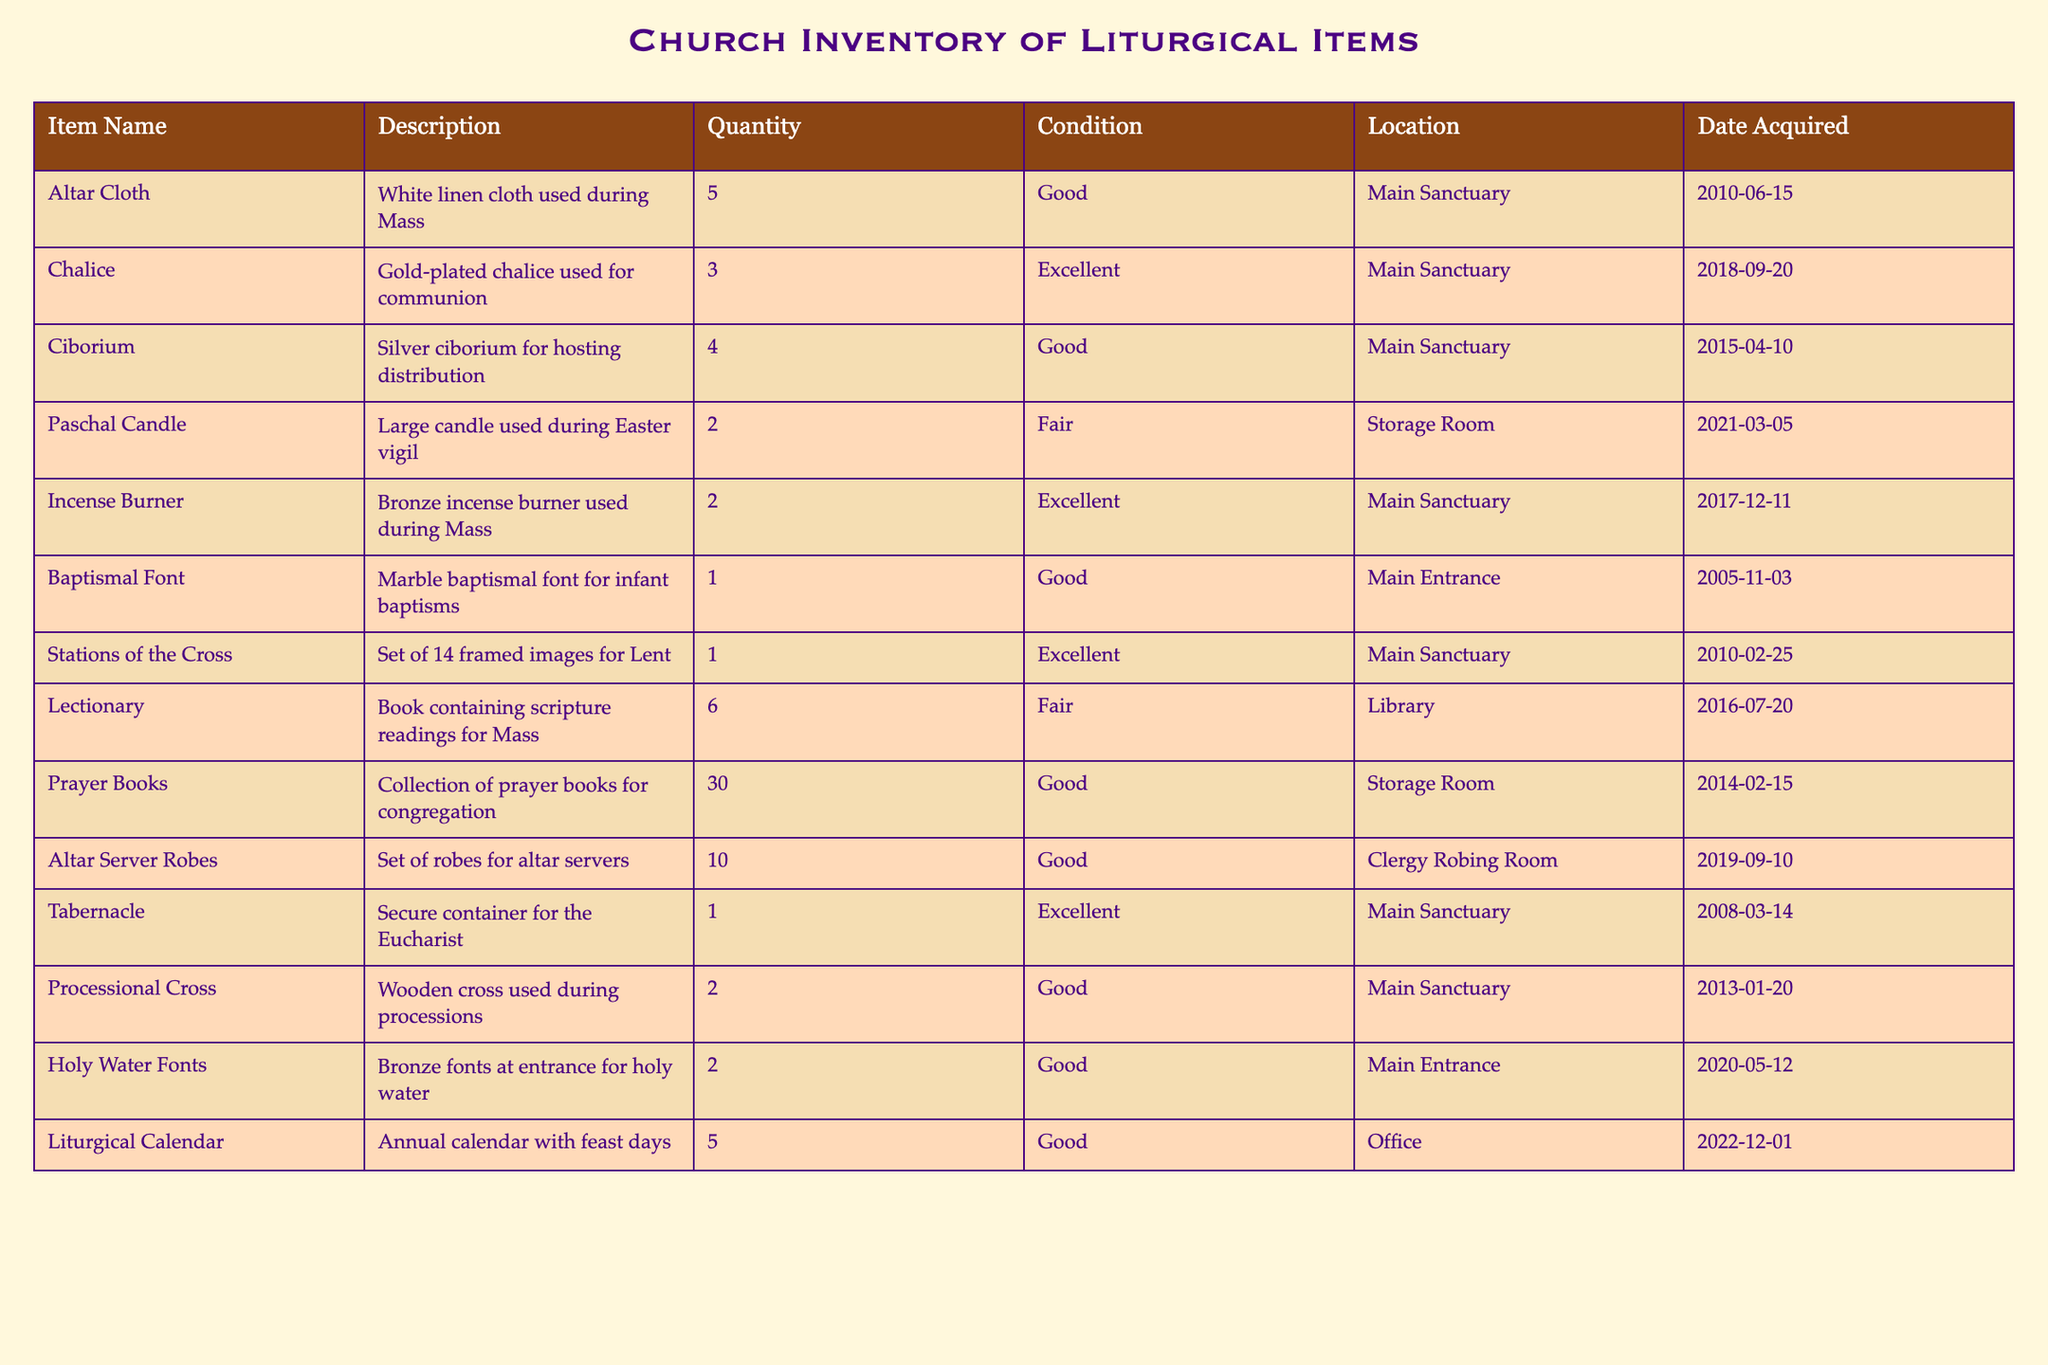What is the total quantity of altar items in the Main Sanctuary? The table lists several altar items located in the Main Sanctuary, which are the Altar Cloth, Chalice, Ciborium, Incense Burner, Tabernacle, Processional Cross, and Stations of the Cross. Their quantities are 5, 3, 4, 2, 1, 2, and 1 respectively. Adding these quantities together: 5 + 3 + 4 + 2 + 1 + 2 + 1 = 18.
Answer: 18 How many items are in fair condition? From the table, the only items listed in fair condition are the Paschal Candle and the Lectionary, which make a total of 2.
Answer: 2 Is there a baptismal font in good condition? Yes, the table indicates that there is a baptismal font, which is in good condition.
Answer: Yes Which liturgical item has the highest quantity? The Prayer Books have the highest quantity, listed as 30 in the table.
Answer: Prayer Books What is the average quantity of items in the Main Sanctuary? The items located in the Main Sanctuary and their quantities are the Altar Cloth (5), Chalice (3), Ciborium (4), Incense Burner (2), Tabernacle (1), Processional Cross (2), and Stations of the Cross (1). There are 7 items in total, and the total quantity is (5 + 3 + 4 + 2 + 1 + 2 + 1 = 18). The average is 18 divided by 7, which is approximately 2.57.
Answer: 2.57 How many items were acquired after the year 2015? The items acquired after 2015 include the Paschal Candle (2021), Holy Water Fonts (2020), Liturgical Calendar (2022), and Altar Server Robes (2019). This adds up to 4 items.
Answer: 4 Are there any items in excellent condition located in the Storage Room? No, according to the table, there are no items listed in excellent condition located in the Storage Room.
Answer: No What condition are the Stations of the Cross in? The Stations of the Cross are listed in excellent condition in the table.
Answer: Excellent 